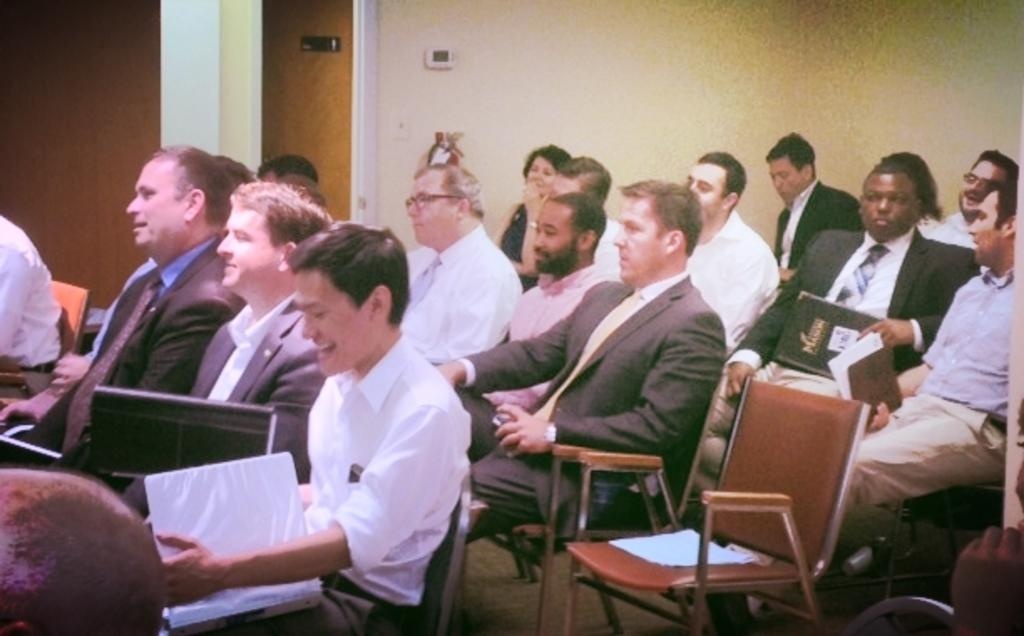What are the people in the image doing? The people in the image are sitting on chairs. What are the people holding in their hands? The people are holding files in their hands. Are there any cobwebs visible in the image? There is no mention of cobwebs in the provided facts, so we cannot determine if any are present in the image. 